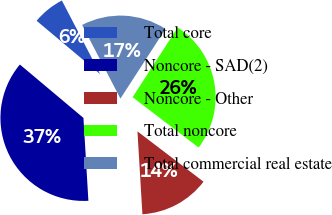Convert chart. <chart><loc_0><loc_0><loc_500><loc_500><pie_chart><fcel>Total core<fcel>Noncore - SAD(2)<fcel>Noncore - Other<fcel>Total noncore<fcel>Total commercial real estate<nl><fcel>6.25%<fcel>37.07%<fcel>13.69%<fcel>26.23%<fcel>16.77%<nl></chart> 